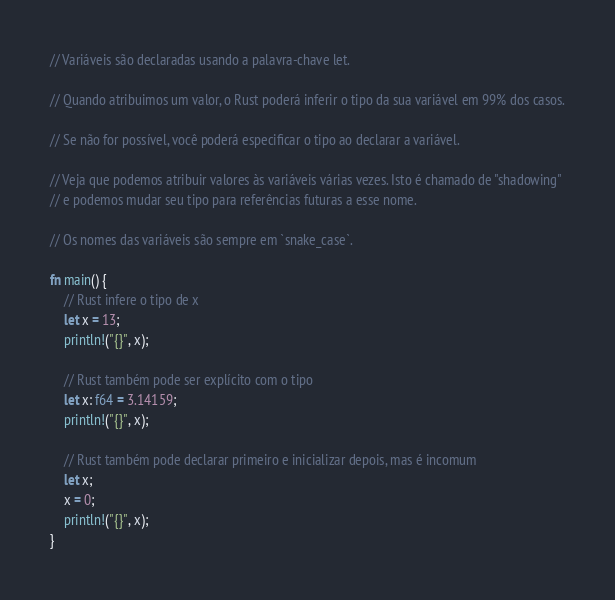<code> <loc_0><loc_0><loc_500><loc_500><_Rust_>// Variáveis são declaradas usando a palavra-chave let.

// Quando atribuimos um valor, o Rust poderá inferir o tipo da sua variável em 99% dos casos.

// Se não for possível, você poderá especificar o tipo ao declarar a variável.

// Veja que podemos atribuir valores às variáveis várias vezes. Isto é chamado de "shadowing"
// e podemos mudar seu tipo para referências futuras a esse nome.

// Os nomes das variáveis são sempre em `snake_case`.

fn main() {
    // Rust infere o tipo de x
    let x = 13;
    println!("{}", x);

    // Rust também pode ser explícito com o tipo
    let x: f64 = 3.14159;
    println!("{}", x);

    // Rust também pode declarar primeiro e inicializar depois, mas é incomum
    let x;
    x = 0;
    println!("{}", x);
}</code> 